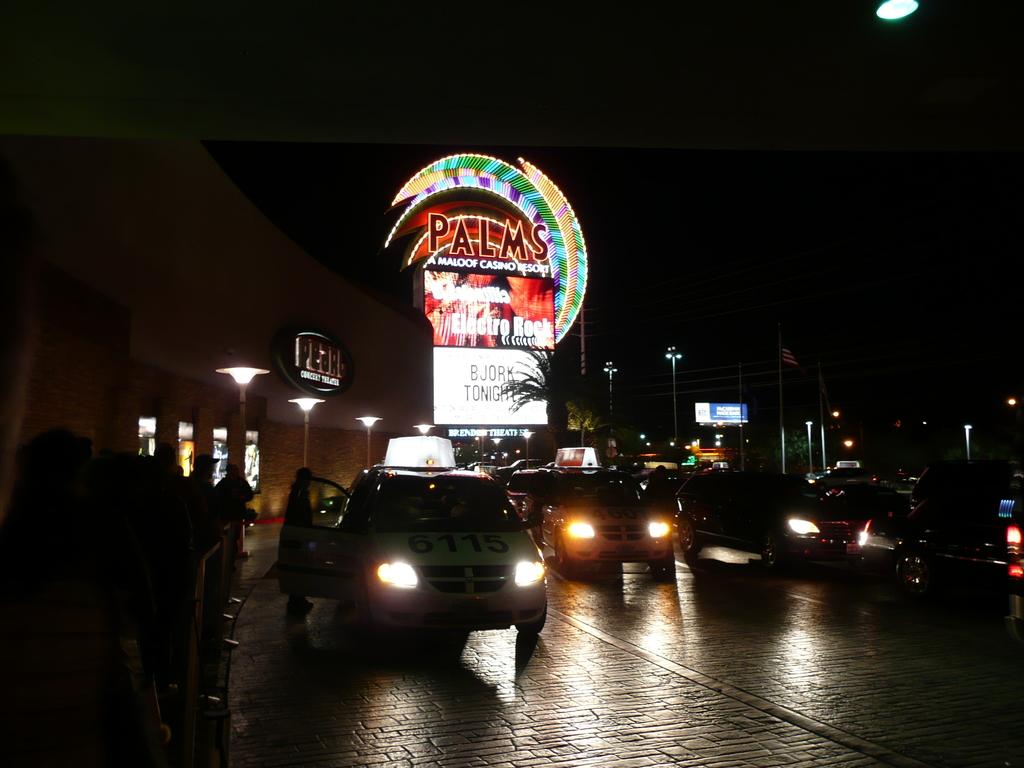What casino is this?
Your answer should be compact. Palms. 